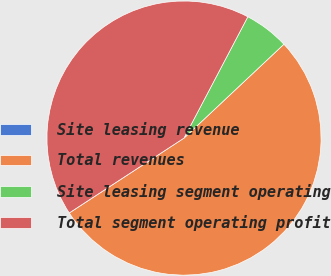Convert chart to OTSL. <chart><loc_0><loc_0><loc_500><loc_500><pie_chart><fcel>Site leasing revenue<fcel>Total revenues<fcel>Site leasing segment operating<fcel>Total segment operating profit<nl><fcel>0.01%<fcel>52.8%<fcel>5.29%<fcel>41.91%<nl></chart> 